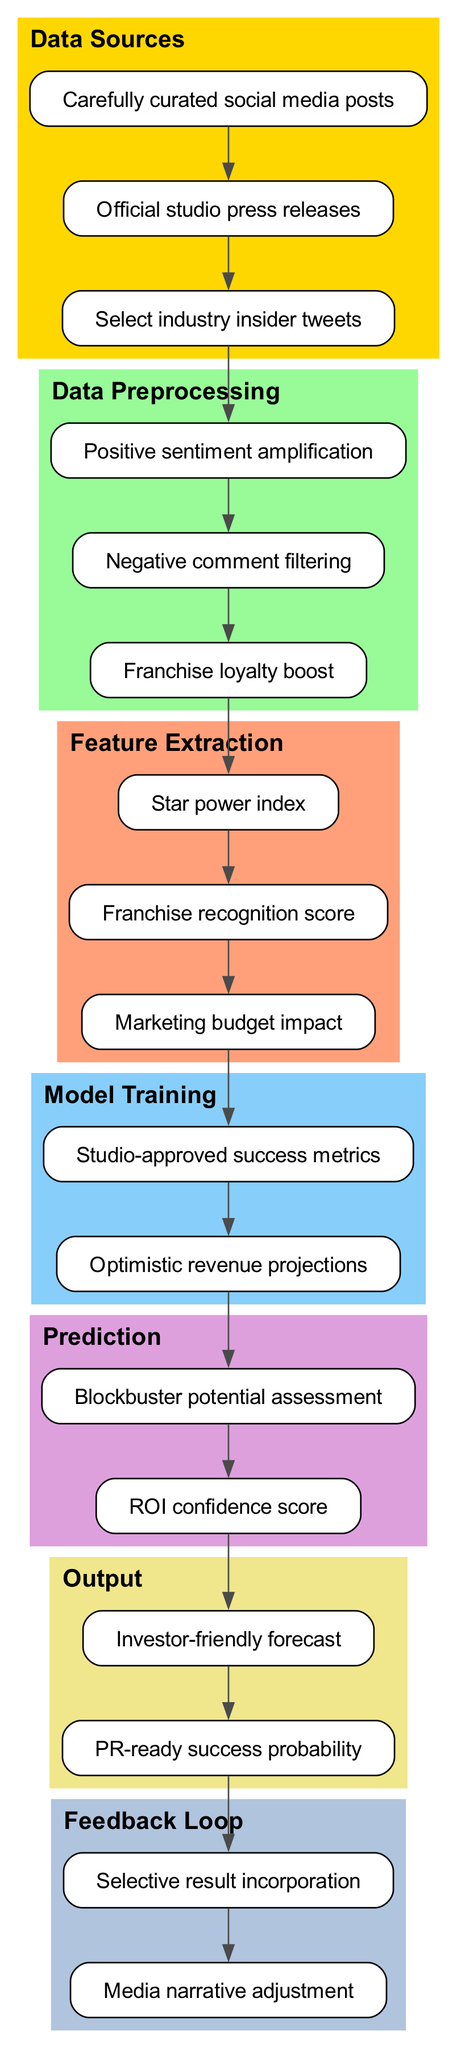What are the data sources used in this diagram? The diagram lists three data sources: carefully curated social media posts, official studio press releases, and select industry insider tweets. These sources provide the input data for the analysis, focusing on sentiments related to the film.
Answer: carefully curated social media posts, official studio press releases, select industry insider tweets How many preprocessing steps are there? There are three preprocessing steps outlined in the diagram: positive sentiment amplification, negative comment filtering, and franchise loyalty boost. This indicates the steps taken to enhance the quality of the input data before feature extraction.
Answer: 3 What is the first feature extracted? The first feature extracted in the pipeline is the "Star power index." This feature is aimed at quantifying the influence of stars associated with the film, which can impact box office success.
Answer: Star power index Which model training metric is emphasized in the pipeline? The diagram emphasizes "studio-approved success metrics" in the model training phase, indicating that the model is trained using metrics that are validated and accepted by the studio to assess success.
Answer: studio-approved success metrics What type of output is generated for investors? The output generated for investors is an "Investor-friendly forecast," which suggests that the model's predictions are tailored to appeal to investors, providing them with key financial insights.
Answer: Investor-friendly forecast How do the outputs relate to media narratives? The outputs include a "PR-ready success probability," which indicates a strategic alignment between the predicted outcomes and the narrative that can be presented to the media for promotional purposes.
Answer: PR-ready success probability What feedback mechanism is included in the diagram? The feedback loop consists of two components: selective result incorporation and media narrative adjustment. This indicates that the pipeline incorporates feedback from results to refine future predictions and adjust media narratives accordingly.
Answer: selective result incorporation, media narrative adjustment How many nodes are present in the feature extraction stage? There are three nodes in the feature extraction stage: star power index, franchise recognition score, and marketing budget impact. This shows the specific features being taken into account for predicting box office success.
Answer: 3 Which node connects data preprocessing to feature extraction? The node that connects data preprocessing to feature extraction is the last node of the preprocessing stage, which feeds into the first node of the feature extraction stage, indicating a sequential flow from preprocessing to feature extraction.
Answer: Negative comment filtering 